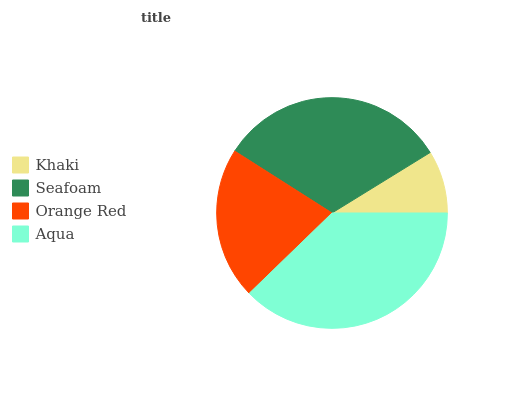Is Khaki the minimum?
Answer yes or no. Yes. Is Aqua the maximum?
Answer yes or no. Yes. Is Seafoam the minimum?
Answer yes or no. No. Is Seafoam the maximum?
Answer yes or no. No. Is Seafoam greater than Khaki?
Answer yes or no. Yes. Is Khaki less than Seafoam?
Answer yes or no. Yes. Is Khaki greater than Seafoam?
Answer yes or no. No. Is Seafoam less than Khaki?
Answer yes or no. No. Is Seafoam the high median?
Answer yes or no. Yes. Is Orange Red the low median?
Answer yes or no. Yes. Is Aqua the high median?
Answer yes or no. No. Is Seafoam the low median?
Answer yes or no. No. 